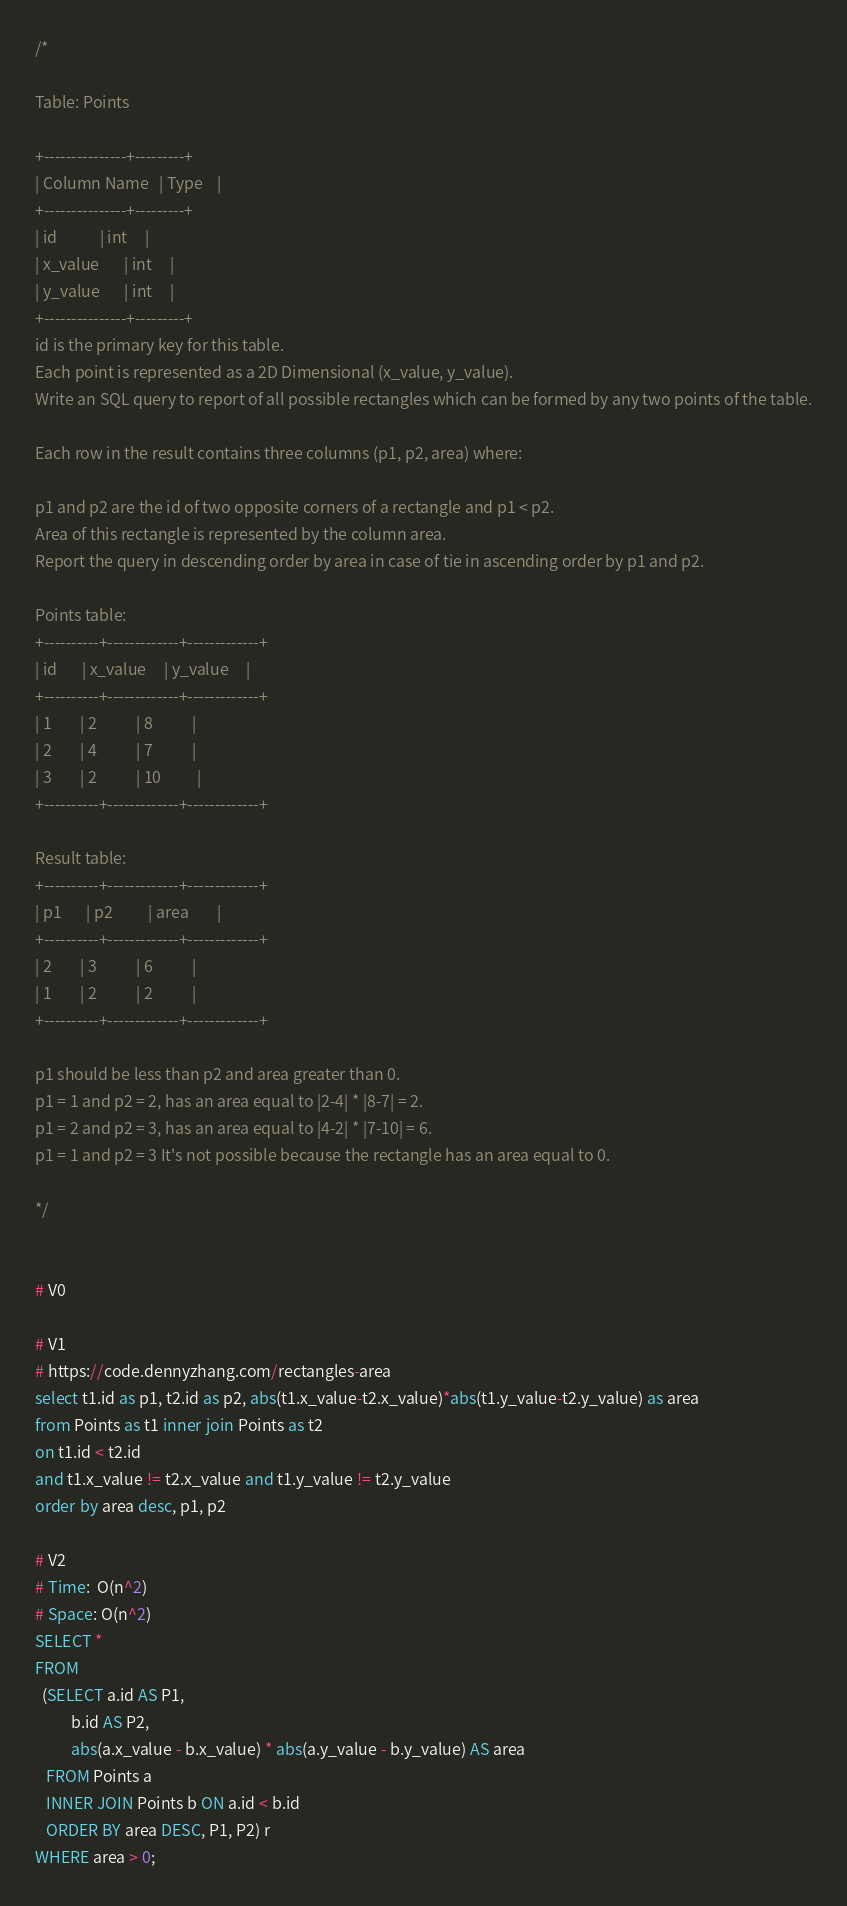<code> <loc_0><loc_0><loc_500><loc_500><_SQL_>/*

Table: Points

+---------------+---------+
| Column Name   | Type    |
+---------------+---------+
| id            | int     |
| x_value       | int     |
| y_value       | int     |
+---------------+---------+
id is the primary key for this table.
Each point is represented as a 2D Dimensional (x_value, y_value).
Write an SQL query to report of all possible rectangles which can be formed by any two points of the table.

Each row in the result contains three columns (p1, p2, area) where:

p1 and p2 are the id of two opposite corners of a rectangle and p1 < p2.
Area of this rectangle is represented by the column area.
Report the query in descending order by area in case of tie in ascending order by p1 and p2.

Points table:
+----------+-------------+-------------+
| id       | x_value     | y_value     |
+----------+-------------+-------------+
| 1        | 2           | 8           |
| 2        | 4           | 7           |
| 3        | 2           | 10          |
+----------+-------------+-------------+

Result table:
+----------+-------------+-------------+
| p1       | p2          | area        |
+----------+-------------+-------------+
| 2        | 3           | 6           |
| 1        | 2           | 2           |
+----------+-------------+-------------+

p1 should be less than p2 and area greater than 0.
p1 = 1 and p2 = 2, has an area equal to |2-4| * |8-7| = 2.
p1 = 2 and p2 = 3, has an area equal to |4-2| * |7-10| = 6.
p1 = 1 and p2 = 3 It's not possible because the rectangle has an area equal to 0.

*/


# V0

# V1
# https://code.dennyzhang.com/rectangles-area
select t1.id as p1, t2.id as p2, abs(t1.x_value-t2.x_value)*abs(t1.y_value-t2.y_value) as area
from Points as t1 inner join Points as t2
on t1.id < t2.id
and t1.x_value != t2.x_value and t1.y_value != t2.y_value
order by area desc, p1, p2

# V2
# Time:  O(n^2)
# Space: O(n^2)
SELECT *
FROM
  (SELECT a.id AS P1,
          b.id AS P2,
          abs(a.x_value - b.x_value) * abs(a.y_value - b.y_value) AS area
   FROM Points a
   INNER JOIN Points b ON a.id < b.id
   ORDER BY area DESC, P1, P2) r
WHERE area > 0;</code> 